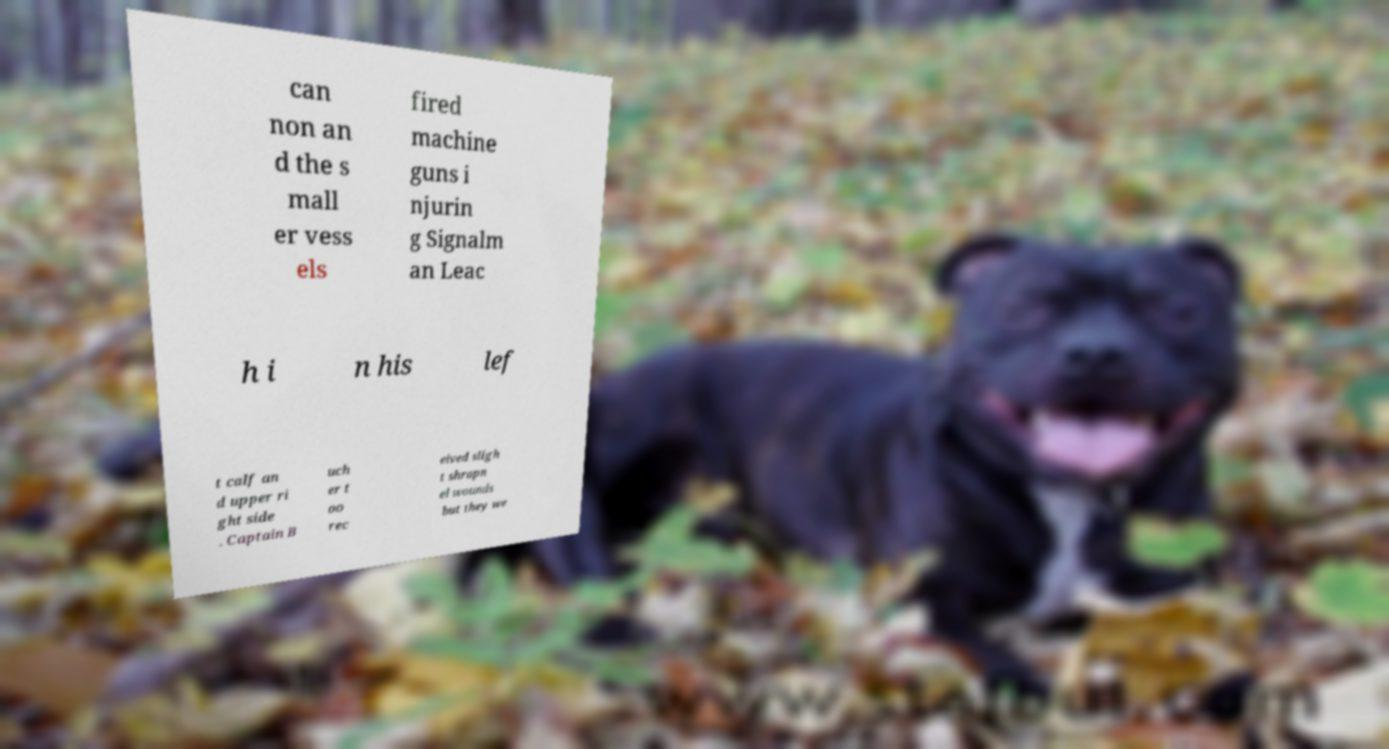Could you assist in decoding the text presented in this image and type it out clearly? can non an d the s mall er vess els fired machine guns i njurin g Signalm an Leac h i n his lef t calf an d upper ri ght side . Captain B uch er t oo rec eived sligh t shrapn el wounds but they we 